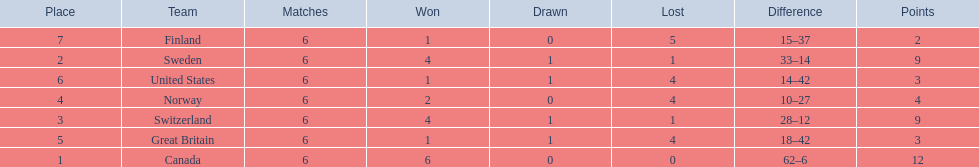What team placed after canada? Sweden. 